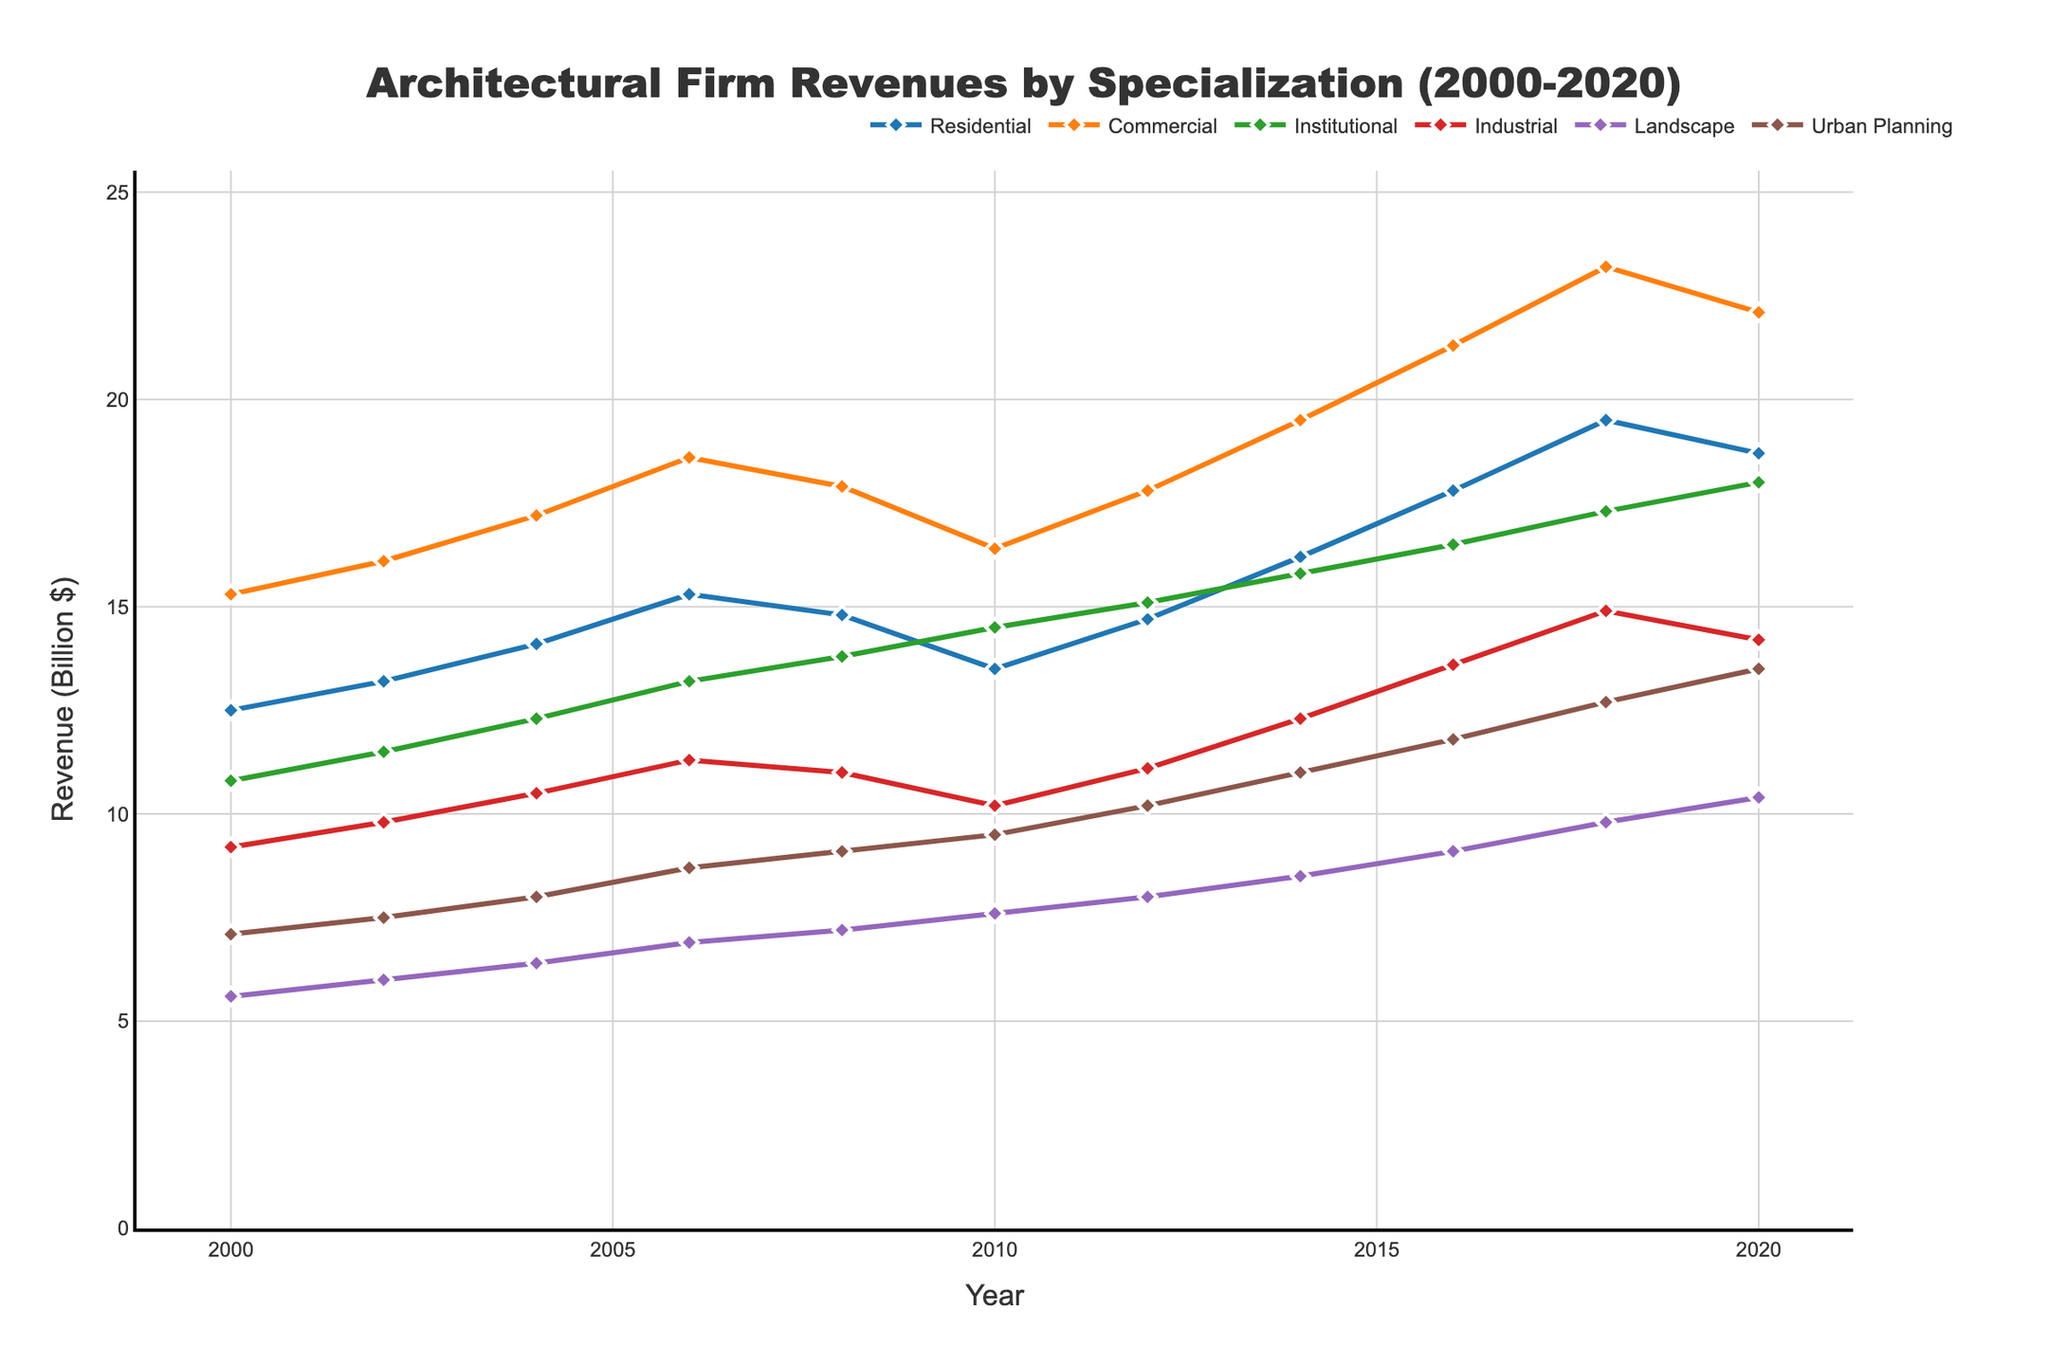What is the revenue trend for Residential specialization from 2000 to 2020? The Residential specialization's revenue starts at 12.5 billion dollars in 2000, increases over the years with slight drops in 2008 and 2020, but overall it shows an increasing trend reaching 18.7 billion dollars in 2020.
Answer: Increasing Which specialization had the highest revenue in 2020? Looking at the values in 2020, Commercial specialization had a revenue of 22.1 billion dollars, which is higher than the other specializations.
Answer: Commercial Which specialization experienced the greatest revenue growth between 2000 and 2020? The revenue growth is calculated as the difference between 2020 and 2000 for each specialization. The Commercial specialization grew from 15.3 billion dollars in 2000 to 22.1 billion dollars in 2020, a growth of 6.8 billion dollars, which is the greatest among all specializations.
Answer: Commercial What was the average revenue for Industrial specialization from 2000 to 2020? Adding up the revenue values for Industrial specialization (9.2, 9.8, 10.5, 11.3, 11.0, 10.2, 11.1, 12.3, 13.6, 14.9, 14.2) equals 127.1 billion dollars. Dividing by the number of years (11), the average is 11.55 billion dollars.
Answer: 11.55 billion dollars Which specializations showed a revenue decline at any point during the period 2000-2020? Reviewing each line, Residential shows a decline from 2008 to 2010, and from 2018 to 2020. Commercial shows a decline from 2008 to 2010, and Institutional from 2008 to 2010. Industrial also shows temporary declines during these years. Therefore, the specializations showing a revenue decline at some point are Residential, Commercial, Institutional, and Industrial.
Answer: Residential, Commercial, Institutional, Industrial What is the difference in revenue between Landscape and Urban Planning specializations in 2020? In 2020, the revenue for Landscape is 10.4 billion dollars and for Urban Planning is 13.5 billion dollars. The difference is 13.5 - 10.4 = 3.1 billion dollars.
Answer: 3.1 billion dollars How did the revenue for Institutional specialization change between 2000 and 2010? The revenue for Institutional specialization in 2000 was 10.8 billion dollars and increased steadily to 14.5 billion dollars by 2010. The change is calculated as 14.5 - 10.8 = 3.7 billion dollars increase.
Answer: 3.7 billion dollars increase Which specialization had the closest revenue to 15 billion dollars in 2014? In 2014, the specialization with revenue closest to 15 billion dollars is Institutional, which had a revenue of 15.8 billion dollars.
Answer: Institutional Compare the revenue of Residential and Industrial specializations in 2018. Which was higher and by how much? In 2018, the revenue for Residential specialization was 19.5 billion dollars and for Industrial specialization it was 14.9 billion dollars. Residential was higher by 19.5 - 14.9 = 4.6 billion dollars.
Answer: Residential by 4.6 billion dollars What was the combined revenue for Urban Planning and Landscape specializations in 2010? In 2010, the revenue for Urban Planning was 9.5 billion dollars and for Landscape it was 7.6 billion dollars. The combined revenue is 9.5 + 7.6 = 17.1 billion dollars.
Answer: 17.1 billion dollars 